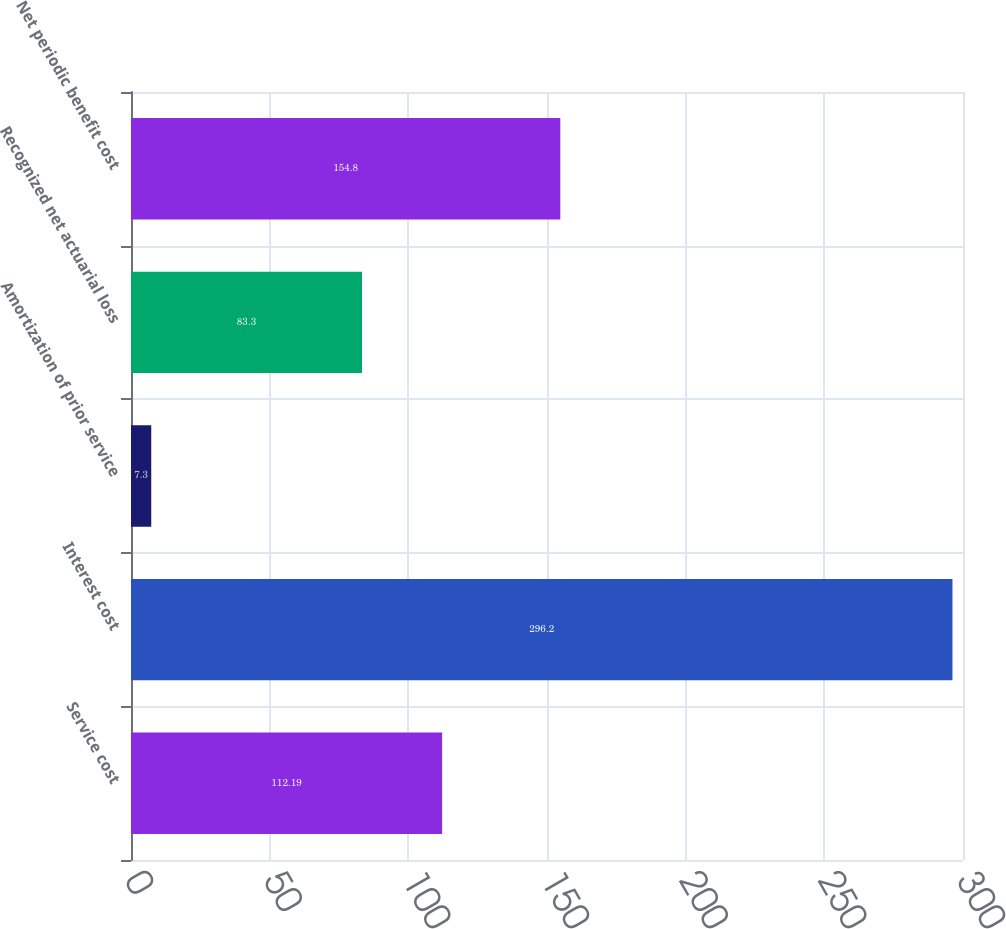Convert chart. <chart><loc_0><loc_0><loc_500><loc_500><bar_chart><fcel>Service cost<fcel>Interest cost<fcel>Amortization of prior service<fcel>Recognized net actuarial loss<fcel>Net periodic benefit cost<nl><fcel>112.19<fcel>296.2<fcel>7.3<fcel>83.3<fcel>154.8<nl></chart> 